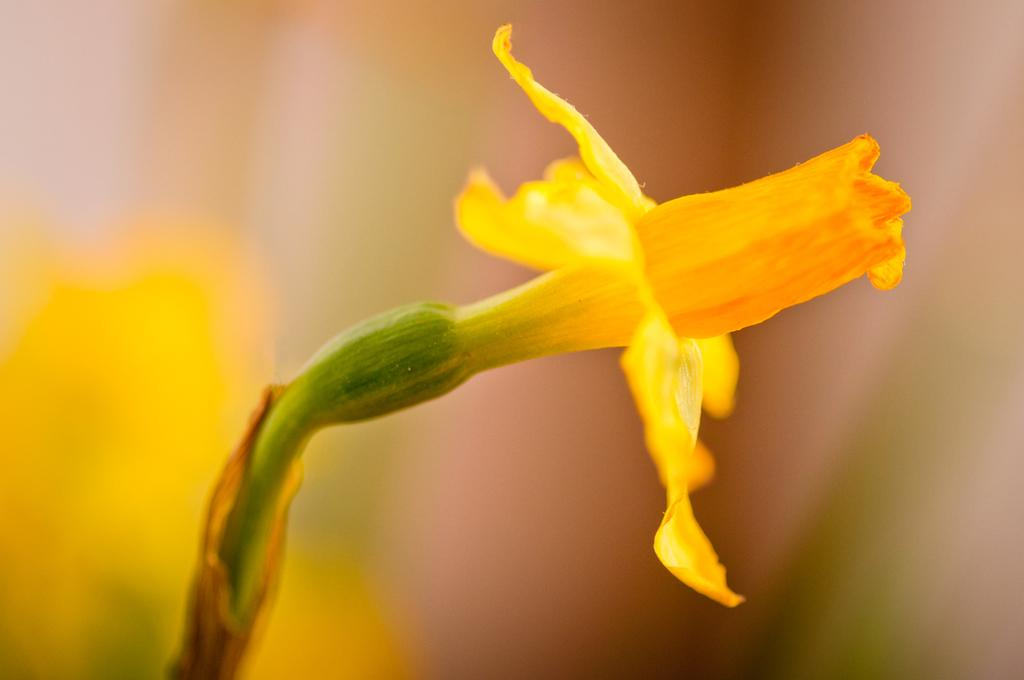What is the main subject of the image? There is a flower in the image. Where is the flower located? The flower is on a plant. What color is the flower? The flower is yellow. Can you describe the background of the image? The background of the image is blurred. How many quarters can be seen on the flower in the image? There are no quarters present in the image; it features a yellow flower on a plant. Are there any trucks visible in the background of the image? There are no trucks present in the image; the background is blurred. 